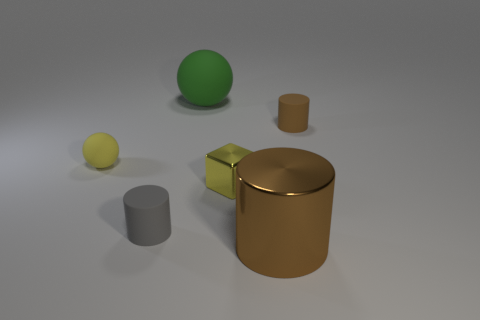Are there fewer tiny blocks to the right of the yellow block than big green matte objects behind the large brown shiny cylinder?
Your response must be concise. Yes. What number of other things are there of the same material as the green ball
Your response must be concise. 3. There is a gray object that is the same size as the block; what material is it?
Offer a terse response. Rubber. How many brown things are big matte cylinders or large metallic cylinders?
Offer a very short reply. 1. There is a tiny thing that is both in front of the small yellow sphere and left of the large rubber sphere; what is its color?
Ensure brevity in your answer.  Gray. Do the small object that is in front of the small block and the big thing in front of the small yellow metal block have the same material?
Make the answer very short. No. Are there more small yellow things to the right of the big green ball than tiny matte balls that are on the right side of the yellow metallic object?
Offer a terse response. Yes. There is a rubber thing that is the same size as the brown shiny cylinder; what is its shape?
Keep it short and to the point. Sphere. What number of objects are small gray matte objects or tiny rubber cylinders to the left of the large green rubber object?
Make the answer very short. 1. Does the small matte ball have the same color as the metal cube?
Keep it short and to the point. Yes. 